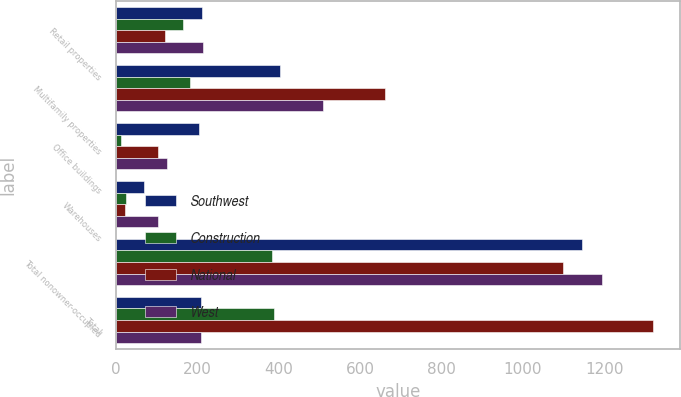Convert chart to OTSL. <chart><loc_0><loc_0><loc_500><loc_500><stacked_bar_chart><ecel><fcel>Retail properties<fcel>Multifamily properties<fcel>Office buildings<fcel>Warehouses<fcel>Total nonowner-occupied<fcel>Total<nl><fcel>Southwest<fcel>212<fcel>402<fcel>204<fcel>68<fcel>1146<fcel>208<nl><fcel>Construction<fcel>165<fcel>182<fcel>12<fcel>25<fcel>384<fcel>387<nl><fcel>National<fcel>119<fcel>662<fcel>102<fcel>21<fcel>1098<fcel>1320<nl><fcel>West<fcel>214<fcel>508<fcel>125<fcel>104<fcel>1194<fcel>208<nl></chart> 